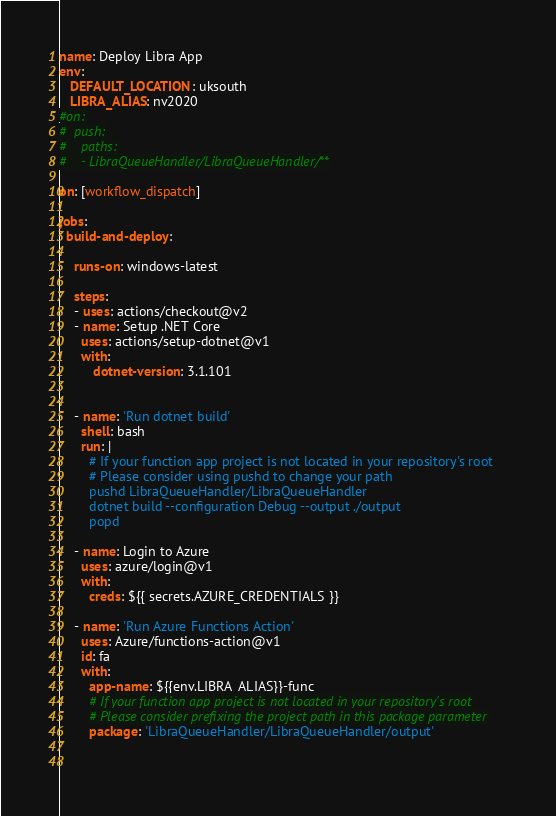<code> <loc_0><loc_0><loc_500><loc_500><_YAML_>name: Deploy Libra App
env:
   DEFAULT_LOCATION: uksouth 
   LIBRA_ALIAS: nv2020
#on:
#  push:
#    paths:
#    - LibraQueueHandler/LibraQueueHandler/**

on: [workflow_dispatch]

jobs:
  build-and-deploy:

    runs-on: windows-latest

    steps:
    - uses: actions/checkout@v2
    - name: Setup .NET Core
      uses: actions/setup-dotnet@v1
      with:
         dotnet-version: 3.1.101
      
    
    - name: 'Run dotnet build'
      shell: bash
      run: |
        # If your function app project is not located in your repository's root
        # Please consider using pushd to change your path
        pushd LibraQueueHandler/LibraQueueHandler
        dotnet build --configuration Debug --output ./output
        popd 
        
    - name: Login to Azure
      uses: azure/login@v1
      with:
        creds: ${{ secrets.AZURE_CREDENTIALS }}
   
    - name: 'Run Azure Functions Action'
      uses: Azure/functions-action@v1
      id: fa
      with:
        app-name: ${{env.LIBRA_ALIAS}}-func
        # If your function app project is not located in your repository's root
        # Please consider prefixing the project path in this package parameter
        package: 'LibraQueueHandler/LibraQueueHandler/output'
        
       


</code> 